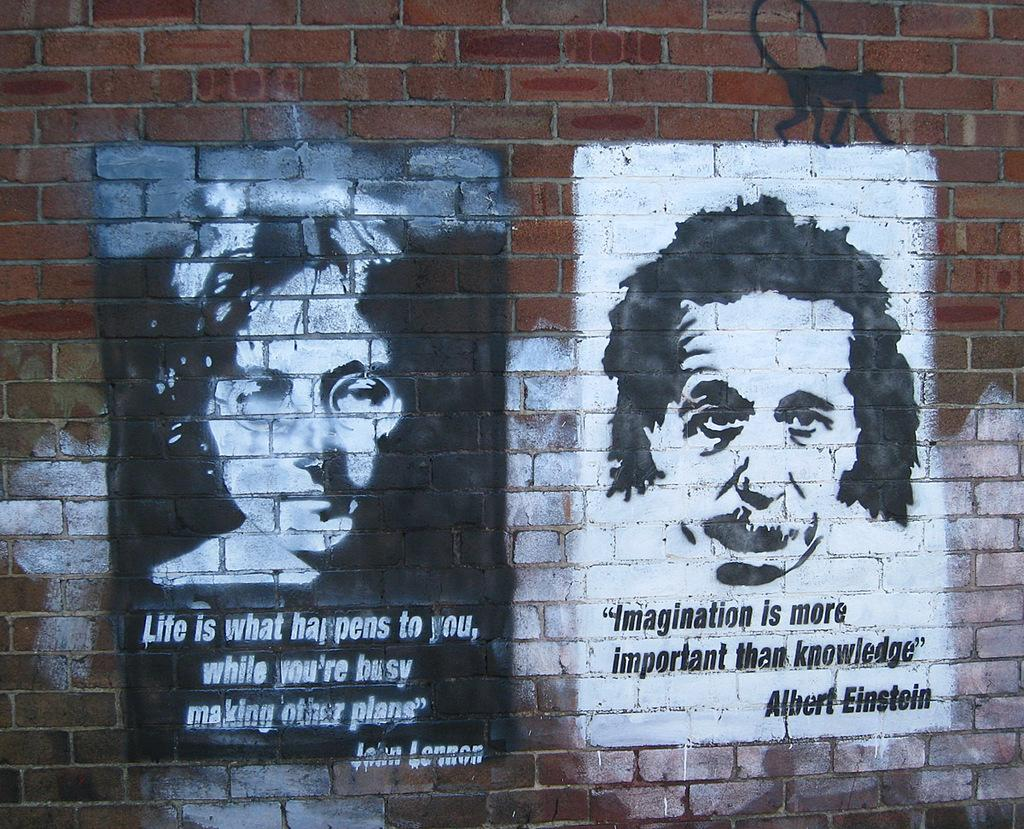What type of structure is visible in the image? There is a brick wall in the image. What is on the brick wall? There is a painting on the wall. What subjects are depicted in the painting? The painting depicts people and a monkey. Are there any words or letters in the painting? Yes, there is text in the painting. What type of soap is being used to clean the monkey in the painting? There is no soap or cleaning activity depicted in the painting; it simply shows people and a monkey. What historical event is being portrayed in the painting? The painting does not depict any specific historical event; it focuses on people and a monkey. 